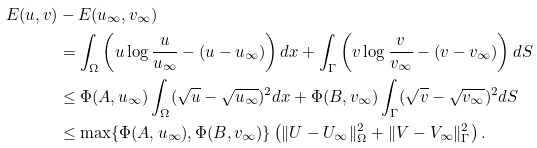<formula> <loc_0><loc_0><loc_500><loc_500>E ( u , v ) & - E ( u _ { \infty } , v _ { \infty } ) \\ & = \int _ { \Omega } \left ( u \log \frac { u } { u _ { \infty } } - ( u - u _ { \infty } ) \right ) d x + \int _ { \Gamma } \left ( v \log \frac { v } { v _ { \infty } } - ( v - v _ { \infty } ) \right ) d S \\ & \leq \Phi ( A , u _ { \infty } ) \int _ { \Omega } ( \sqrt { u } - \sqrt { u _ { \infty } } ) ^ { 2 } d x + \Phi ( B , v _ { \infty } ) \int _ { \Gamma } ( \sqrt { v } - \sqrt { v _ { \infty } } ) ^ { 2 } d S \\ & \leq \max \{ \Phi ( A , u _ { \infty } ) , \Phi ( B , v _ { \infty } ) \} \left ( \| U - U _ { \infty } \| _ { \Omega } ^ { 2 } + \| V - V _ { \infty } \| _ { \Gamma } ^ { 2 } \right ) .</formula> 